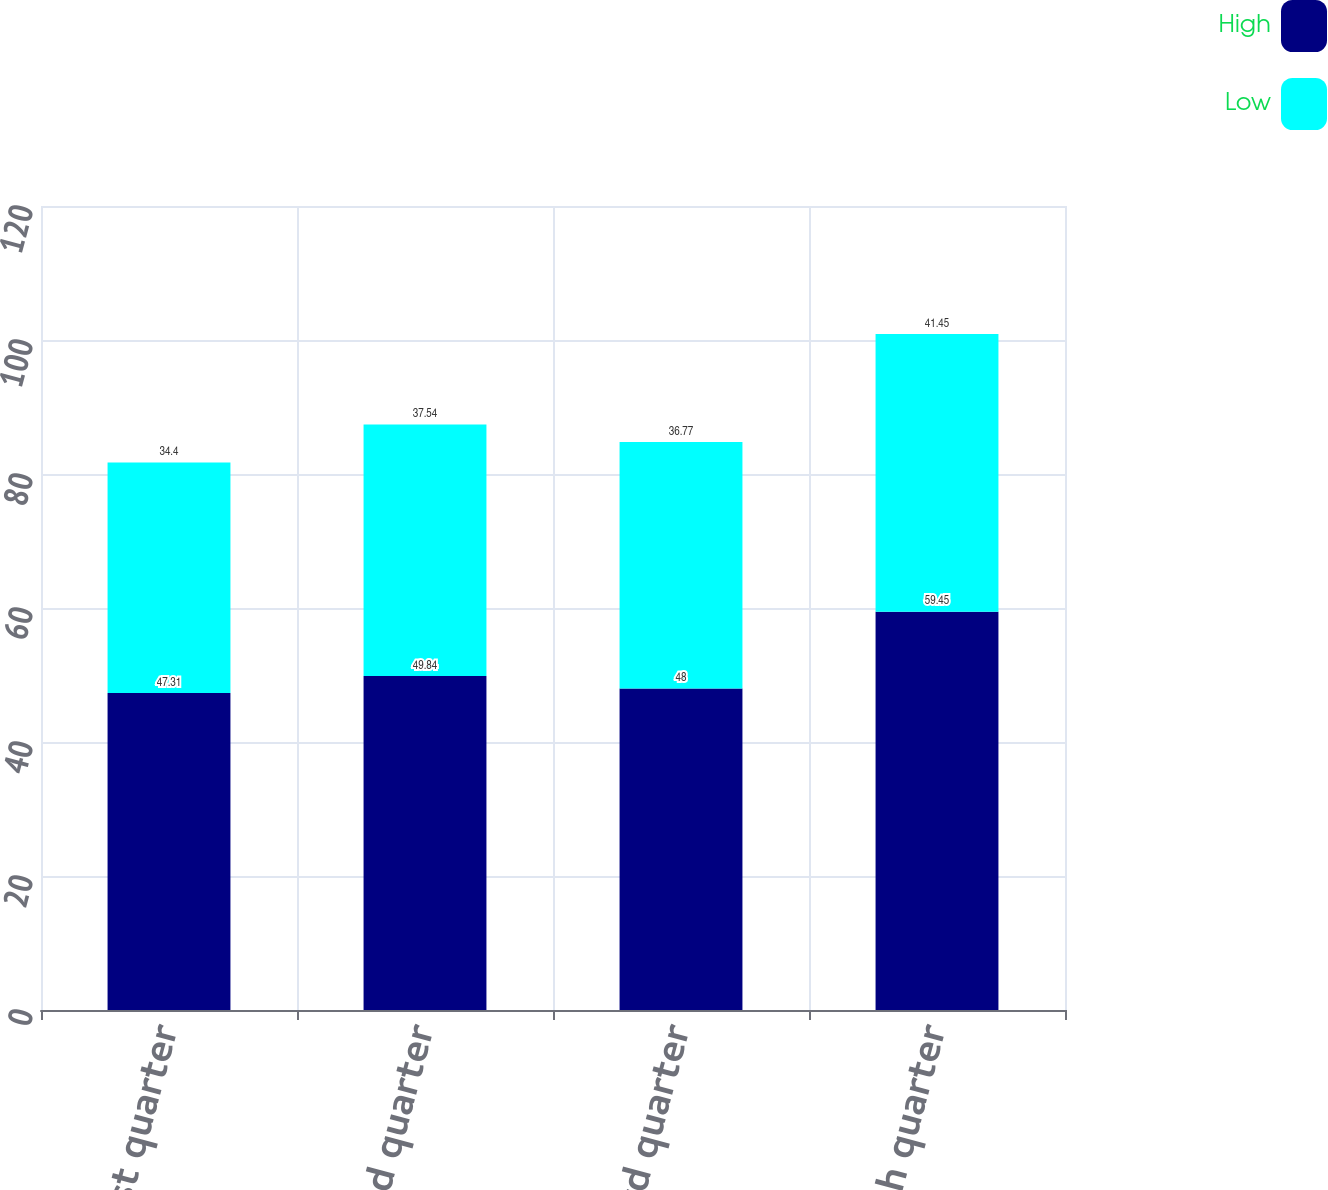<chart> <loc_0><loc_0><loc_500><loc_500><stacked_bar_chart><ecel><fcel>First quarter<fcel>Second quarter<fcel>Third quarter<fcel>Fourth quarter<nl><fcel>High<fcel>47.31<fcel>49.84<fcel>48<fcel>59.45<nl><fcel>Low<fcel>34.4<fcel>37.54<fcel>36.77<fcel>41.45<nl></chart> 